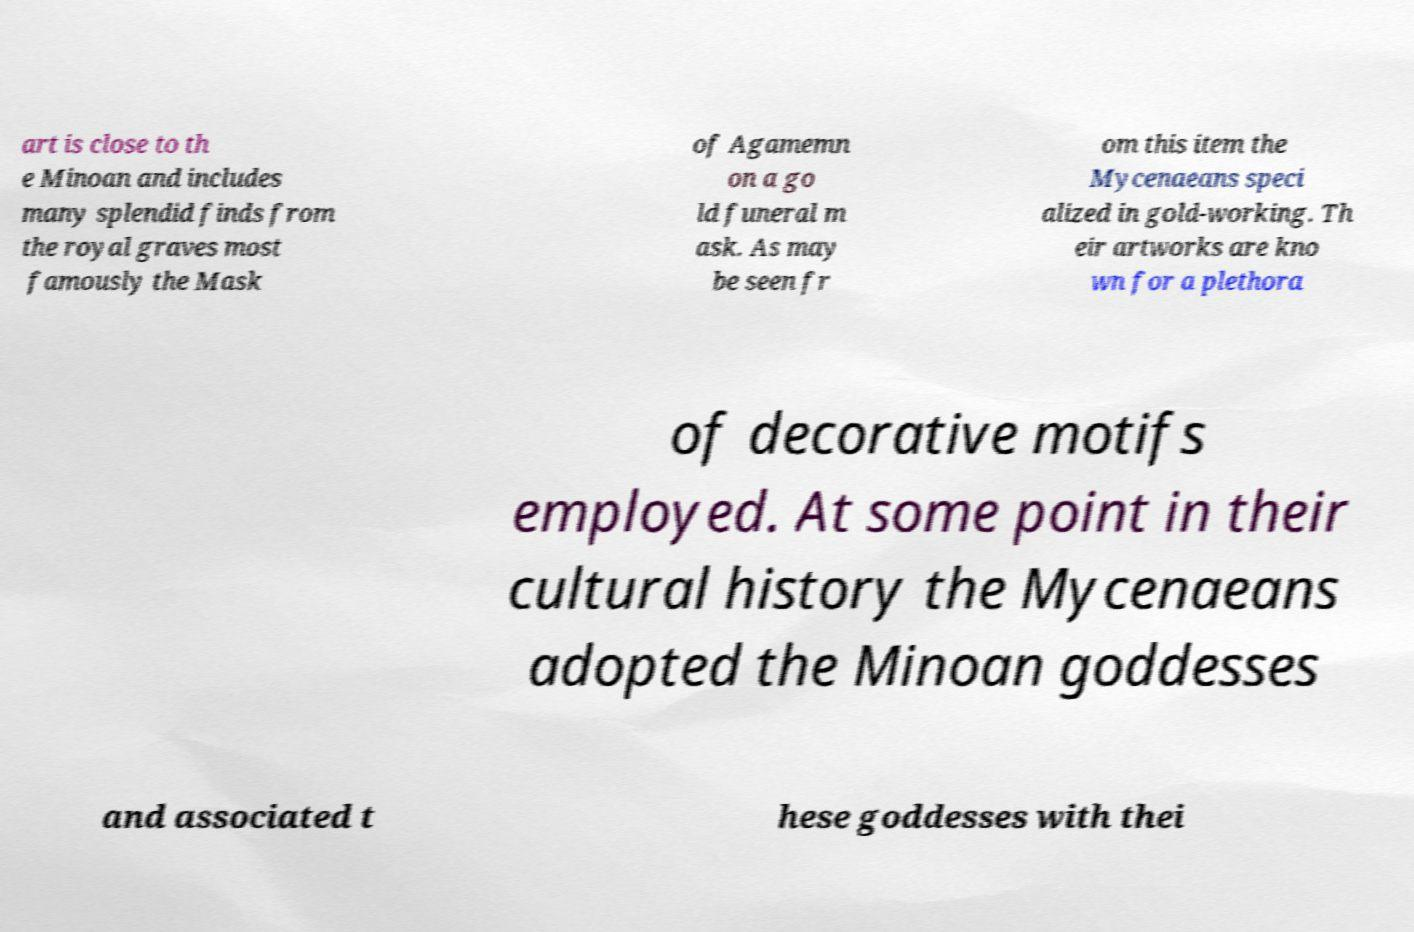Can you accurately transcribe the text from the provided image for me? art is close to th e Minoan and includes many splendid finds from the royal graves most famously the Mask of Agamemn on a go ld funeral m ask. As may be seen fr om this item the Mycenaeans speci alized in gold-working. Th eir artworks are kno wn for a plethora of decorative motifs employed. At some point in their cultural history the Mycenaeans adopted the Minoan goddesses and associated t hese goddesses with thei 